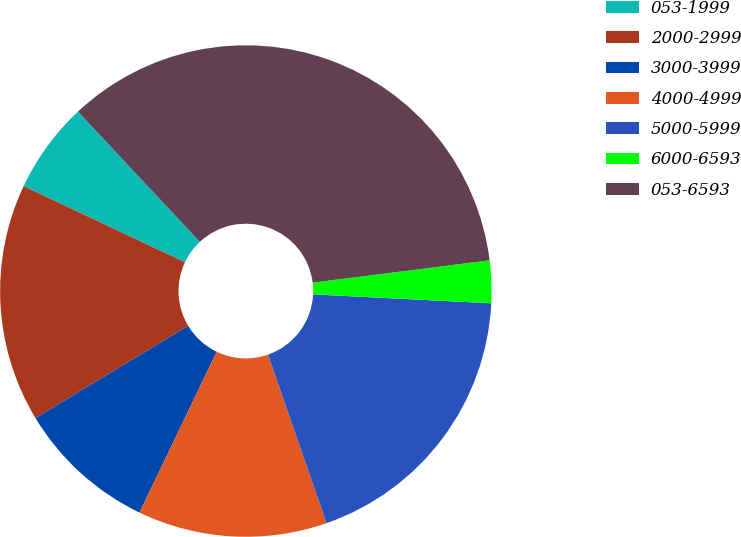<chart> <loc_0><loc_0><loc_500><loc_500><pie_chart><fcel>053-1999<fcel>2000-2999<fcel>3000-3999<fcel>4000-4999<fcel>5000-5999<fcel>6000-6593<fcel>053-6593<nl><fcel>6.01%<fcel>15.67%<fcel>9.23%<fcel>12.45%<fcel>18.88%<fcel>2.79%<fcel>34.98%<nl></chart> 